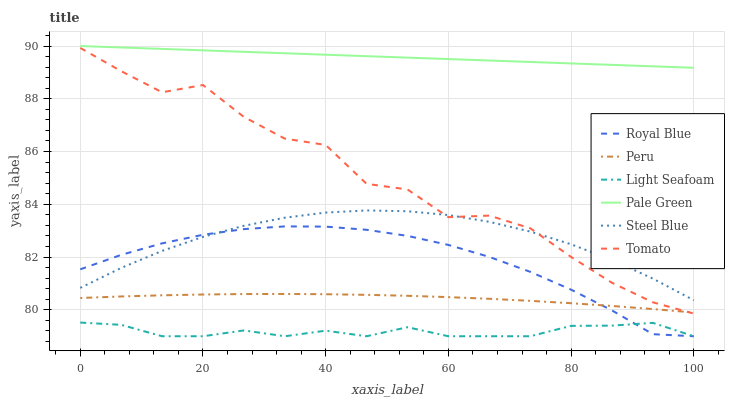Does Steel Blue have the minimum area under the curve?
Answer yes or no. No. Does Steel Blue have the maximum area under the curve?
Answer yes or no. No. Is Steel Blue the smoothest?
Answer yes or no. No. Is Steel Blue the roughest?
Answer yes or no. No. Does Steel Blue have the lowest value?
Answer yes or no. No. Does Steel Blue have the highest value?
Answer yes or no. No. Is Steel Blue less than Pale Green?
Answer yes or no. Yes. Is Steel Blue greater than Light Seafoam?
Answer yes or no. Yes. Does Steel Blue intersect Pale Green?
Answer yes or no. No. 